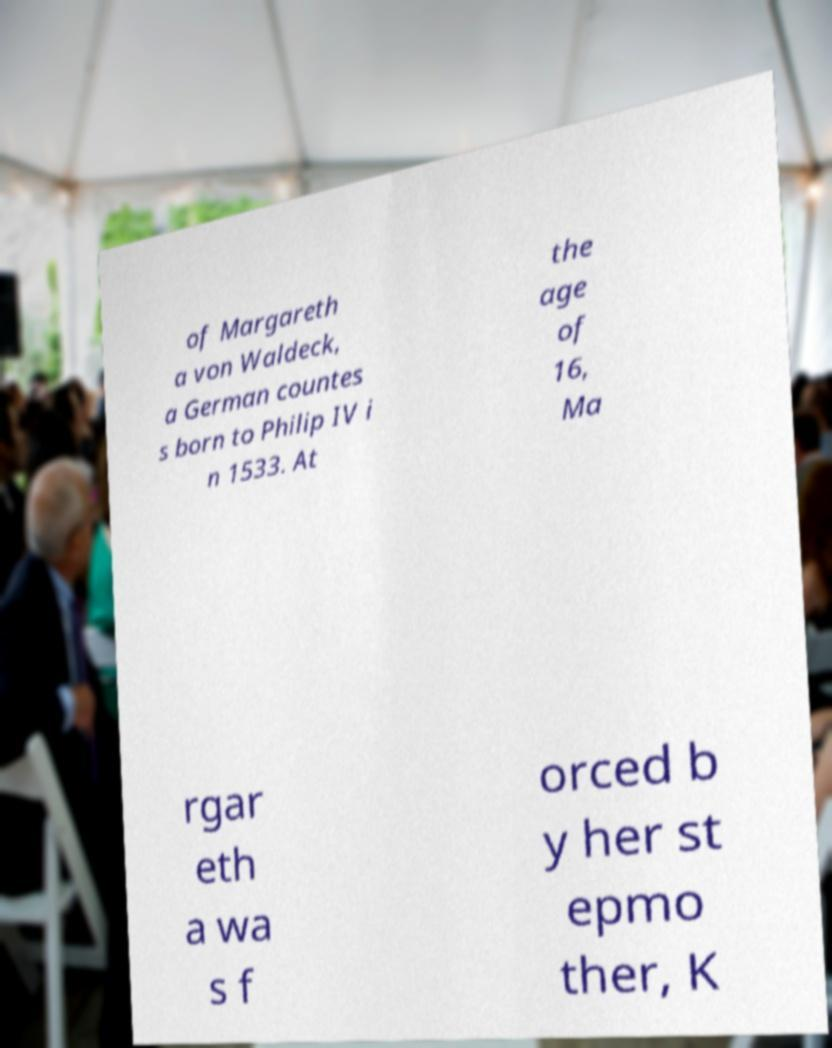For documentation purposes, I need the text within this image transcribed. Could you provide that? of Margareth a von Waldeck, a German countes s born to Philip IV i n 1533. At the age of 16, Ma rgar eth a wa s f orced b y her st epmo ther, K 